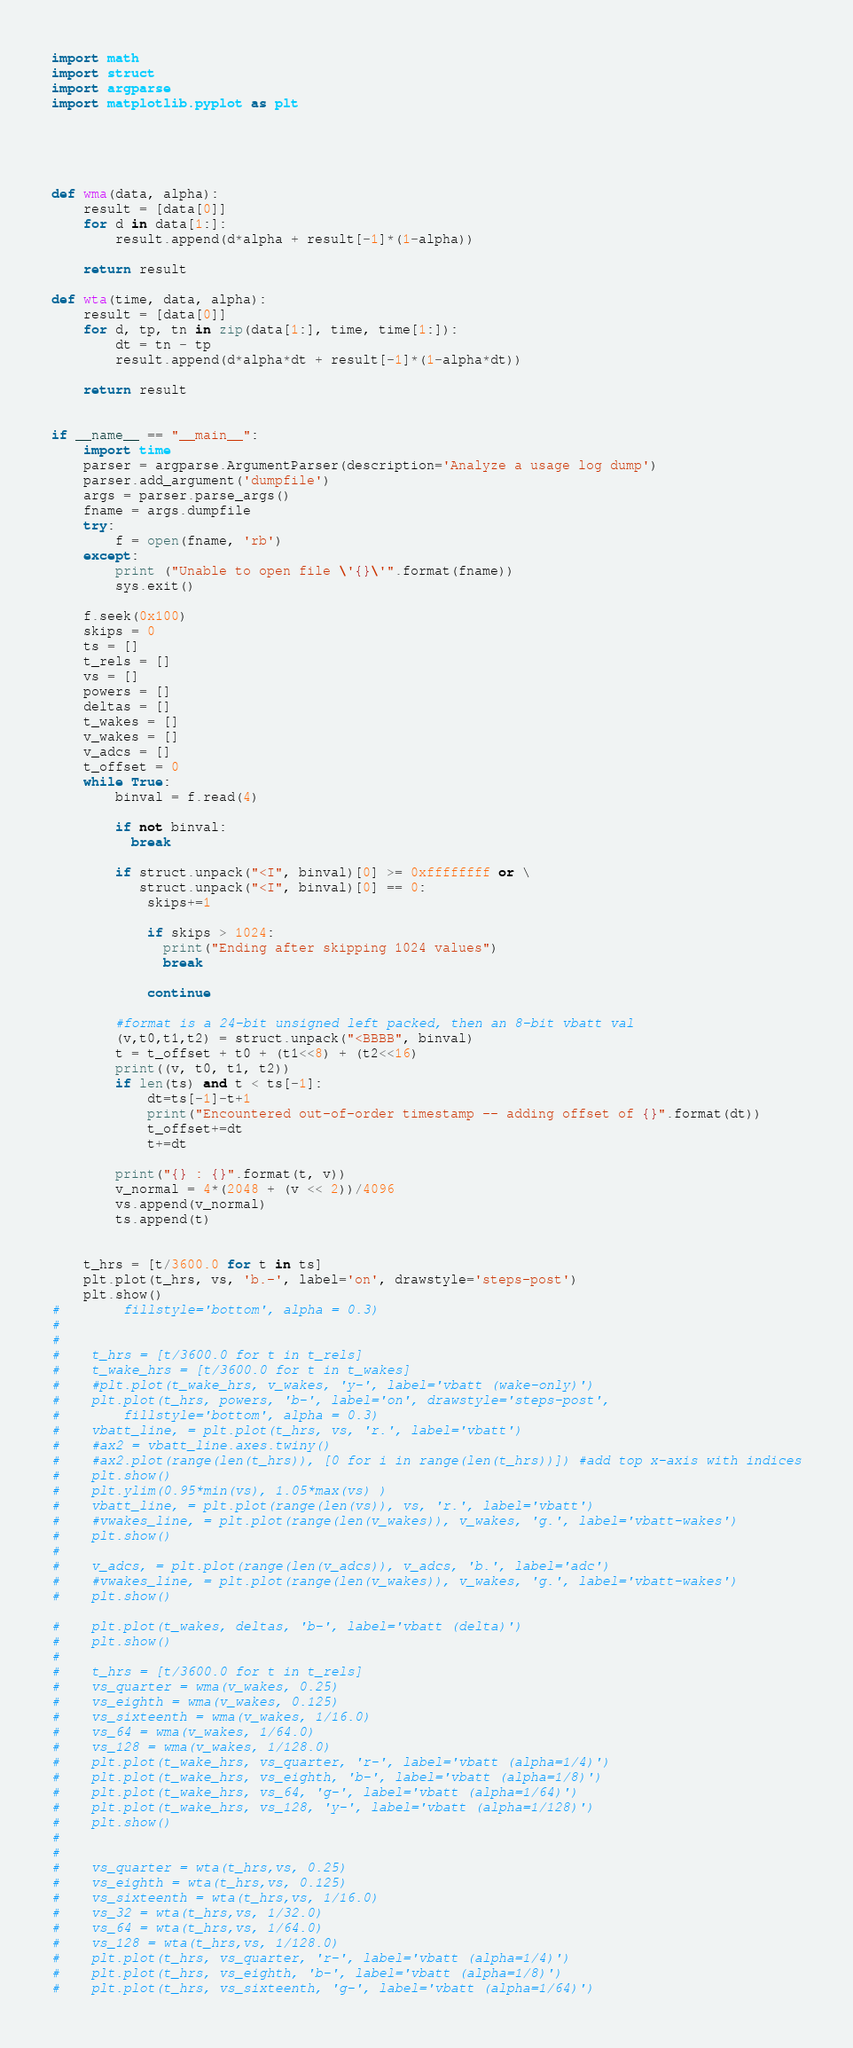Convert code to text. <code><loc_0><loc_0><loc_500><loc_500><_Python_>
import math
import struct
import argparse
import matplotlib.pyplot as plt





def wma(data, alpha):
    result = [data[0]]
    for d in data[1:]:
        result.append(d*alpha + result[-1]*(1-alpha))

    return result

def wta(time, data, alpha):
    result = [data[0]]
    for d, tp, tn in zip(data[1:], time, time[1:]):
        dt = tn - tp
        result.append(d*alpha*dt + result[-1]*(1-alpha*dt))

    return result


if __name__ == "__main__":
    import time
    parser = argparse.ArgumentParser(description='Analyze a usage log dump')
    parser.add_argument('dumpfile')
    args = parser.parse_args()
    fname = args.dumpfile
    try:
        f = open(fname, 'rb')
    except:
        print ("Unable to open file \'{}\'".format(fname))
        sys.exit()
    
    f.seek(0x100)
    skips = 0
    ts = []
    t_rels = []
    vs = []
    powers = []
    deltas = []
    t_wakes = []
    v_wakes = []
    v_adcs = []
    t_offset = 0
    while True:
        binval = f.read(4)

        if not binval:
          break

        if struct.unpack("<I", binval)[0] >= 0xffffffff or \
           struct.unpack("<I", binval)[0] == 0:
            skips+=1

            if skips > 1024:
              print("Ending after skipping 1024 values")
              break

            continue
        
        #format is a 24-bit unsigned left packed, then an 8-bit vbatt val
        (v,t0,t1,t2) = struct.unpack("<BBBB", binval)
        t = t_offset + t0 + (t1<<8) + (t2<<16)
        print((v, t0, t1, t2)) 
        if len(ts) and t < ts[-1]:
            dt=ts[-1]-t+1
            print("Encountered out-of-order timestamp -- adding offset of {}".format(dt))
            t_offset+=dt
            t+=dt

        print("{} : {}".format(t, v))
        v_normal = 4*(2048 + (v << 2))/4096
        vs.append(v_normal)
        ts.append(t)

    
    t_hrs = [t/3600.0 for t in ts]
    plt.plot(t_hrs, vs, 'b.-', label='on', drawstyle='steps-post')
    plt.show()
#        fillstyle='bottom', alpha = 0.3)
#
#
#    t_hrs = [t/3600.0 for t in t_rels]
#    t_wake_hrs = [t/3600.0 for t in t_wakes]
#    #plt.plot(t_wake_hrs, v_wakes, 'y-', label='vbatt (wake-only)')
#    plt.plot(t_hrs, powers, 'b-', label='on', drawstyle='steps-post',
#        fillstyle='bottom', alpha = 0.3)
#    vbatt_line, = plt.plot(t_hrs, vs, 'r.', label='vbatt')
#    #ax2 = vbatt_line.axes.twiny()
#    #ax2.plot(range(len(t_hrs)), [0 for i in range(len(t_hrs))]) #add top x-axis with indices
#    plt.show()
#    plt.ylim(0.95*min(vs), 1.05*max(vs) )
#    vbatt_line, = plt.plot(range(len(vs)), vs, 'r.', label='vbatt')
#    #vwakes_line, = plt.plot(range(len(v_wakes)), v_wakes, 'g.', label='vbatt-wakes')
#    plt.show()
#    
#    v_adcs, = plt.plot(range(len(v_adcs)), v_adcs, 'b.', label='adc')
#    #vwakes_line, = plt.plot(range(len(v_wakes)), v_wakes, 'g.', label='vbatt-wakes')
#    plt.show()

#    plt.plot(t_wakes, deltas, 'b-', label='vbatt (delta)')
#    plt.show()
#
#    t_hrs = [t/3600.0 for t in t_rels]
#    vs_quarter = wma(v_wakes, 0.25)
#    vs_eighth = wma(v_wakes, 0.125)
#    vs_sixteenth = wma(v_wakes, 1/16.0)
#    vs_64 = wma(v_wakes, 1/64.0)
#    vs_128 = wma(v_wakes, 1/128.0)
#    plt.plot(t_wake_hrs, vs_quarter, 'r-', label='vbatt (alpha=1/4)')
#    plt.plot(t_wake_hrs, vs_eighth, 'b-', label='vbatt (alpha=1/8)')
#    plt.plot(t_wake_hrs, vs_64, 'g-', label='vbatt (alpha=1/64)')
#    plt.plot(t_wake_hrs, vs_128, 'y-', label='vbatt (alpha=1/128)')
#    plt.show()
#
#
#    vs_quarter = wta(t_hrs,vs, 0.25)
#    vs_eighth = wta(t_hrs,vs, 0.125)
#    vs_sixteenth = wta(t_hrs,vs, 1/16.0)
#    vs_32 = wta(t_hrs,vs, 1/32.0)
#    vs_64 = wta(t_hrs,vs, 1/64.0)
#    vs_128 = wta(t_hrs,vs, 1/128.0)
#    plt.plot(t_hrs, vs_quarter, 'r-', label='vbatt (alpha=1/4)')
#    plt.plot(t_hrs, vs_eighth, 'b-', label='vbatt (alpha=1/8)')
#    plt.plot(t_hrs, vs_sixteenth, 'g-', label='vbatt (alpha=1/64)')</code> 